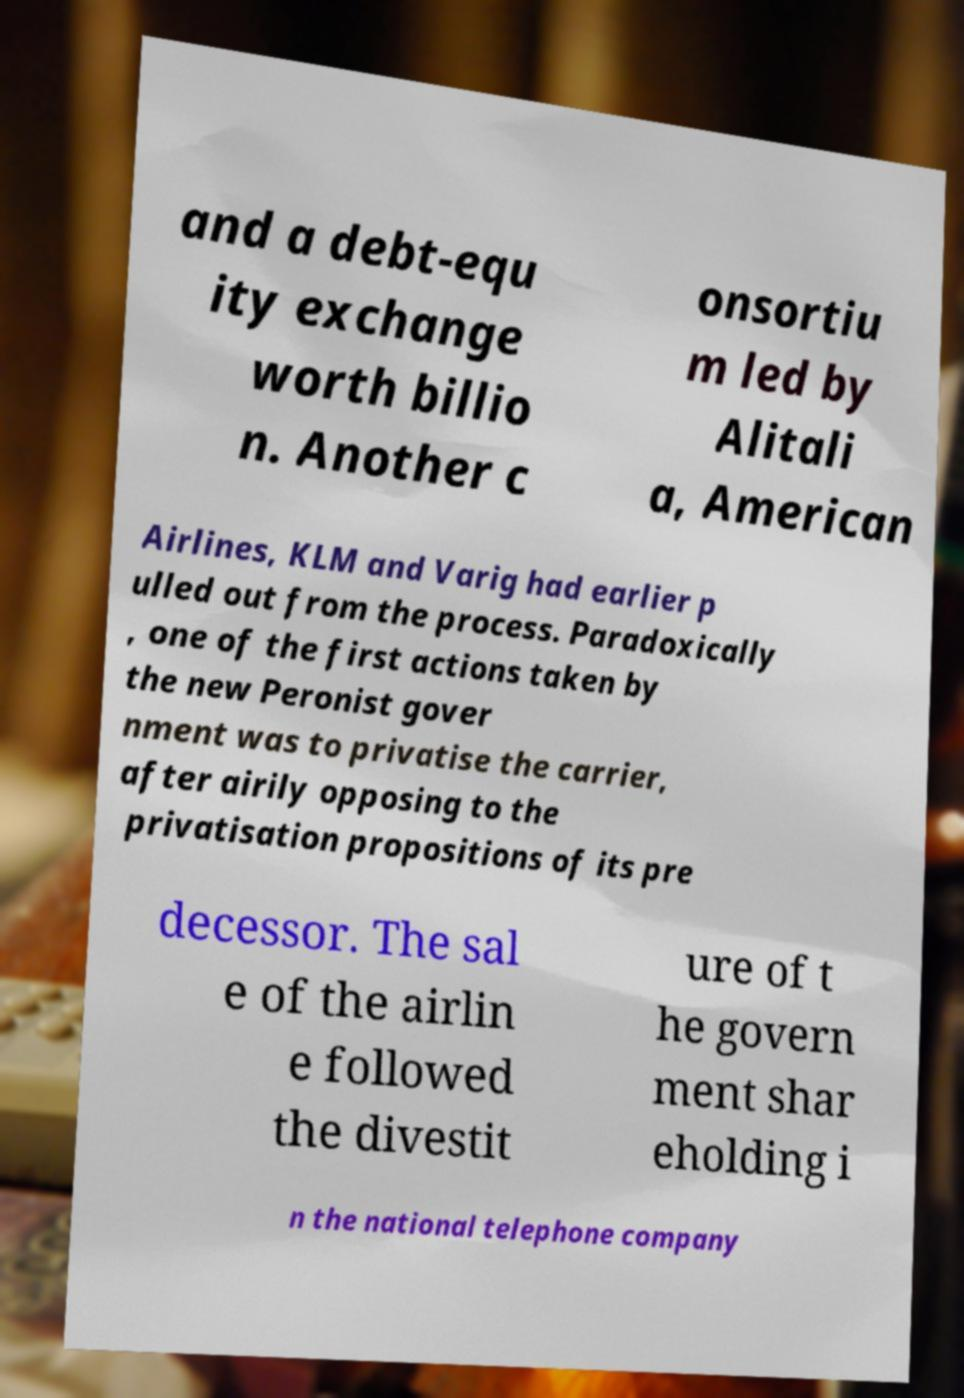Please read and relay the text visible in this image. What does it say? and a debt-equ ity exchange worth billio n. Another c onsortiu m led by Alitali a, American Airlines, KLM and Varig had earlier p ulled out from the process. Paradoxically , one of the first actions taken by the new Peronist gover nment was to privatise the carrier, after airily opposing to the privatisation propositions of its pre decessor. The sal e of the airlin e followed the divestit ure of t he govern ment shar eholding i n the national telephone company 